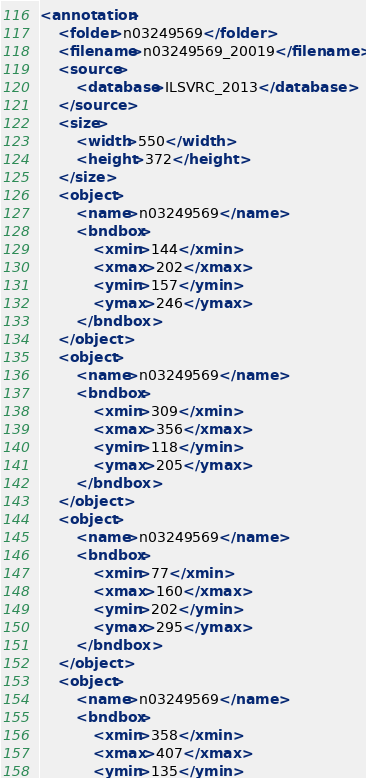Convert code to text. <code><loc_0><loc_0><loc_500><loc_500><_XML_><annotation>
	<folder>n03249569</folder>
	<filename>n03249569_20019</filename>
	<source>
		<database>ILSVRC_2013</database>
	</source>
	<size>
		<width>550</width>
		<height>372</height>
	</size>
	<object>
		<name>n03249569</name>
		<bndbox>
			<xmin>144</xmin>
			<xmax>202</xmax>
			<ymin>157</ymin>
			<ymax>246</ymax>
		</bndbox>
	</object>
	<object>
		<name>n03249569</name>
		<bndbox>
			<xmin>309</xmin>
			<xmax>356</xmax>
			<ymin>118</ymin>
			<ymax>205</ymax>
		</bndbox>
	</object>
	<object>
		<name>n03249569</name>
		<bndbox>
			<xmin>77</xmin>
			<xmax>160</xmax>
			<ymin>202</ymin>
			<ymax>295</ymax>
		</bndbox>
	</object>
	<object>
		<name>n03249569</name>
		<bndbox>
			<xmin>358</xmin>
			<xmax>407</xmax>
			<ymin>135</ymin></code> 